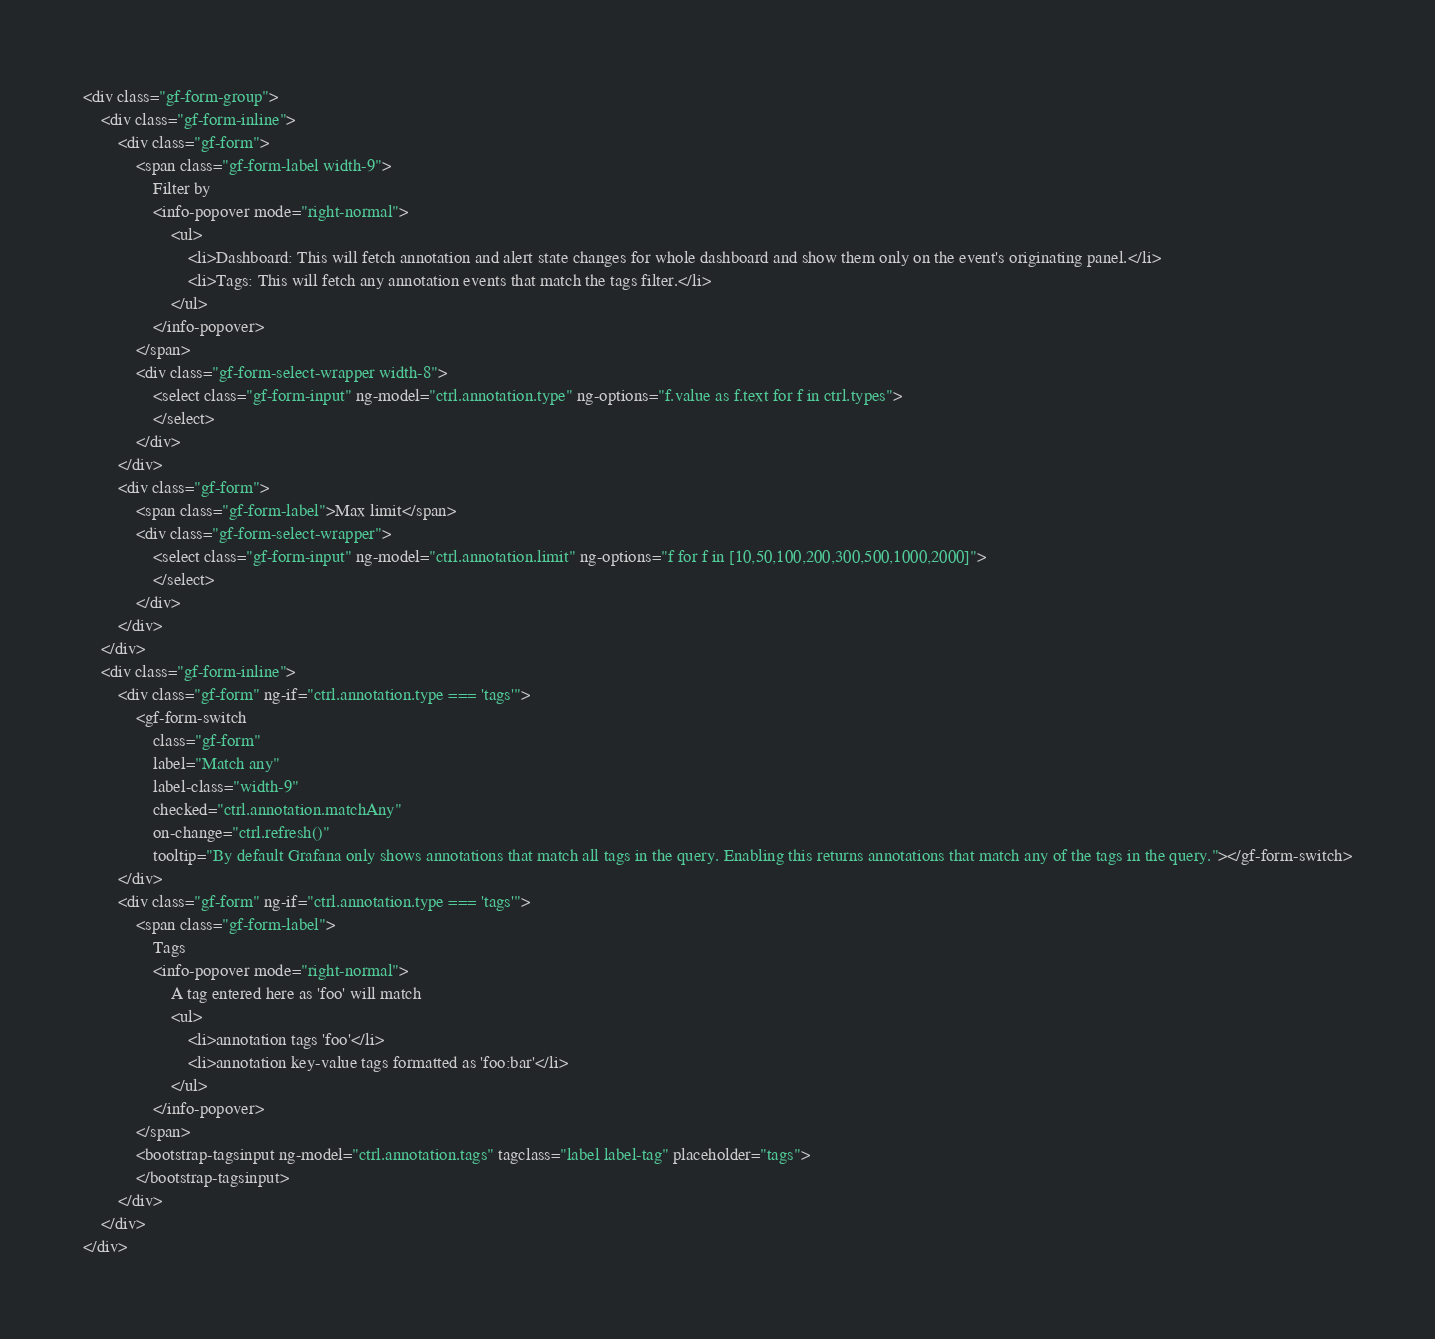<code> <loc_0><loc_0><loc_500><loc_500><_HTML_>
<div class="gf-form-group">
	<div class="gf-form-inline">
		<div class="gf-form">
			<span class="gf-form-label width-9">
				Filter by
				<info-popover mode="right-normal">
					<ul>
						<li>Dashboard: This will fetch annotation and alert state changes for whole dashboard and show them only on the event's originating panel.</li>
						<li>Tags: This will fetch any annotation events that match the tags filter.</li>
					</ul>
				</info-popover>
			</span>
			<div class="gf-form-select-wrapper width-8">
				<select class="gf-form-input" ng-model="ctrl.annotation.type" ng-options="f.value as f.text for f in ctrl.types">
				</select>
			</div>
		</div>
		<div class="gf-form">
			<span class="gf-form-label">Max limit</span>
			<div class="gf-form-select-wrapper">
				<select class="gf-form-input" ng-model="ctrl.annotation.limit" ng-options="f for f in [10,50,100,200,300,500,1000,2000]">
				</select>
			</div>
		</div>
	</div>
	<div class="gf-form-inline">
		<div class="gf-form" ng-if="ctrl.annotation.type === 'tags'">
			<gf-form-switch
				class="gf-form"
				label="Match any"
				label-class="width-9"
				checked="ctrl.annotation.matchAny"
				on-change="ctrl.refresh()"
				tooltip="By default Grafana only shows annotations that match all tags in the query. Enabling this returns annotations that match any of the tags in the query."></gf-form-switch>
		</div>
		<div class="gf-form" ng-if="ctrl.annotation.type === 'tags'">
			<span class="gf-form-label">
				Tags
				<info-popover mode="right-normal">
					A tag entered here as 'foo' will match
					<ul>
						<li>annotation tags 'foo'</li>
						<li>annotation key-value tags formatted as 'foo:bar'</li>
					</ul>
				</info-popover>
			</span>
			<bootstrap-tagsinput ng-model="ctrl.annotation.tags" tagclass="label label-tag" placeholder="tags">
			</bootstrap-tagsinput>
		</div>
	</div>
</div>


</code> 